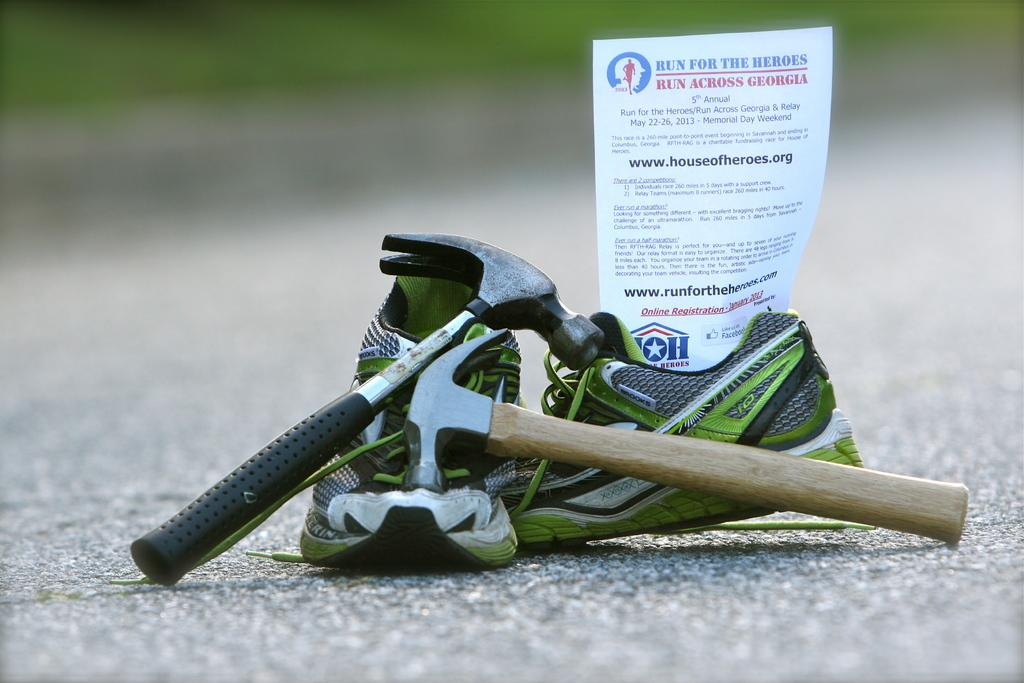What type of objects are in the image? There are shoes, paper, and framing hammers in the image. Can you describe the shoes in the image? Unfortunately, the facts provided do not give any details about the shoes. What is the paper used for in the image? The facts provided do not give any details about the purpose of the paper. What are the framing hammers used for in the image? The framing hammers are likely used for framing or construction purposes, but the facts provided do not give any specific details about their use. How many flowers are visible in the image? There are no flowers present in the image. What type of cart is being used to transport the shoes in the image? There is no cart present in the image, and the facts provided do not mention any transportation of the shoes. 